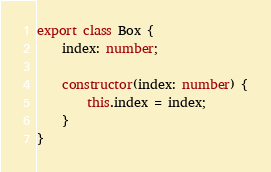Convert code to text. <code><loc_0><loc_0><loc_500><loc_500><_TypeScript_>export class Box {
    index: number;

    constructor(index: number) {
        this.index = index;
    }
}</code> 